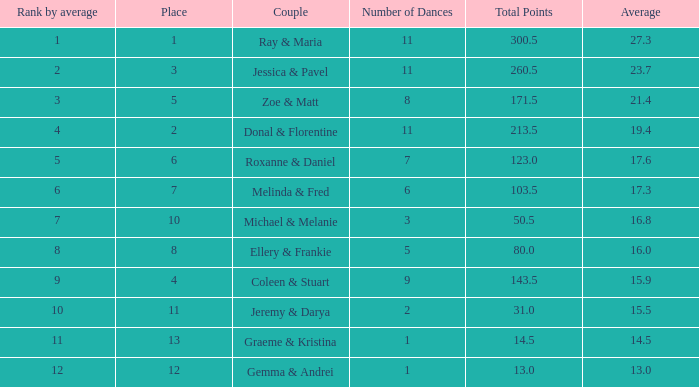If the total points is 50.5, what is the total number of dances? 1.0. 